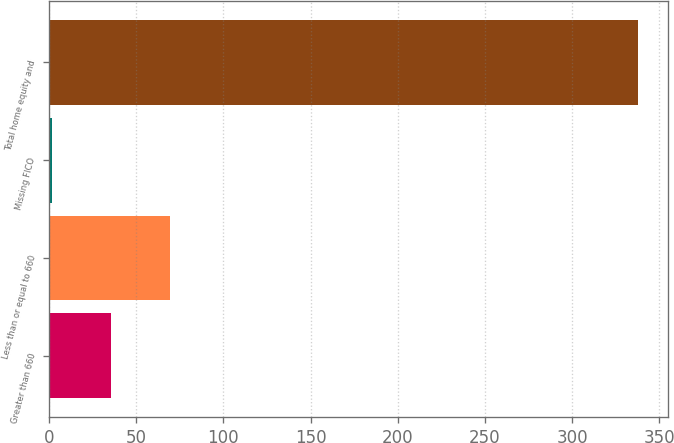Convert chart to OTSL. <chart><loc_0><loc_0><loc_500><loc_500><bar_chart><fcel>Greater than 660<fcel>Less than or equal to 660<fcel>Missing FICO<fcel>Total home equity and<nl><fcel>35.6<fcel>69.2<fcel>2<fcel>338<nl></chart> 